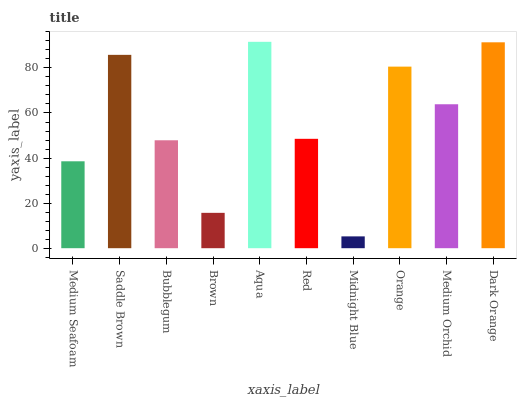Is Midnight Blue the minimum?
Answer yes or no. Yes. Is Aqua the maximum?
Answer yes or no. Yes. Is Saddle Brown the minimum?
Answer yes or no. No. Is Saddle Brown the maximum?
Answer yes or no. No. Is Saddle Brown greater than Medium Seafoam?
Answer yes or no. Yes. Is Medium Seafoam less than Saddle Brown?
Answer yes or no. Yes. Is Medium Seafoam greater than Saddle Brown?
Answer yes or no. No. Is Saddle Brown less than Medium Seafoam?
Answer yes or no. No. Is Medium Orchid the high median?
Answer yes or no. Yes. Is Red the low median?
Answer yes or no. Yes. Is Saddle Brown the high median?
Answer yes or no. No. Is Bubblegum the low median?
Answer yes or no. No. 